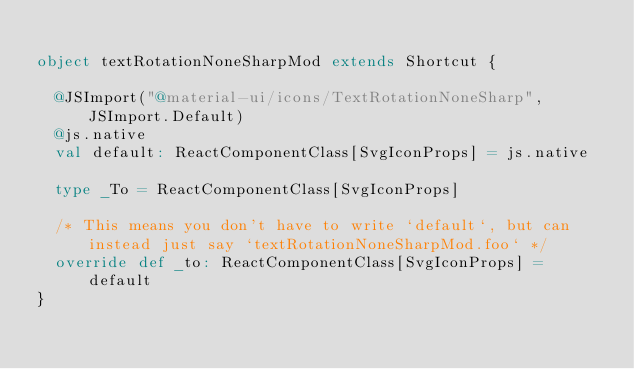<code> <loc_0><loc_0><loc_500><loc_500><_Scala_>
object textRotationNoneSharpMod extends Shortcut {
  
  @JSImport("@material-ui/icons/TextRotationNoneSharp", JSImport.Default)
  @js.native
  val default: ReactComponentClass[SvgIconProps] = js.native
  
  type _To = ReactComponentClass[SvgIconProps]
  
  /* This means you don't have to write `default`, but can instead just say `textRotationNoneSharpMod.foo` */
  override def _to: ReactComponentClass[SvgIconProps] = default
}
</code> 